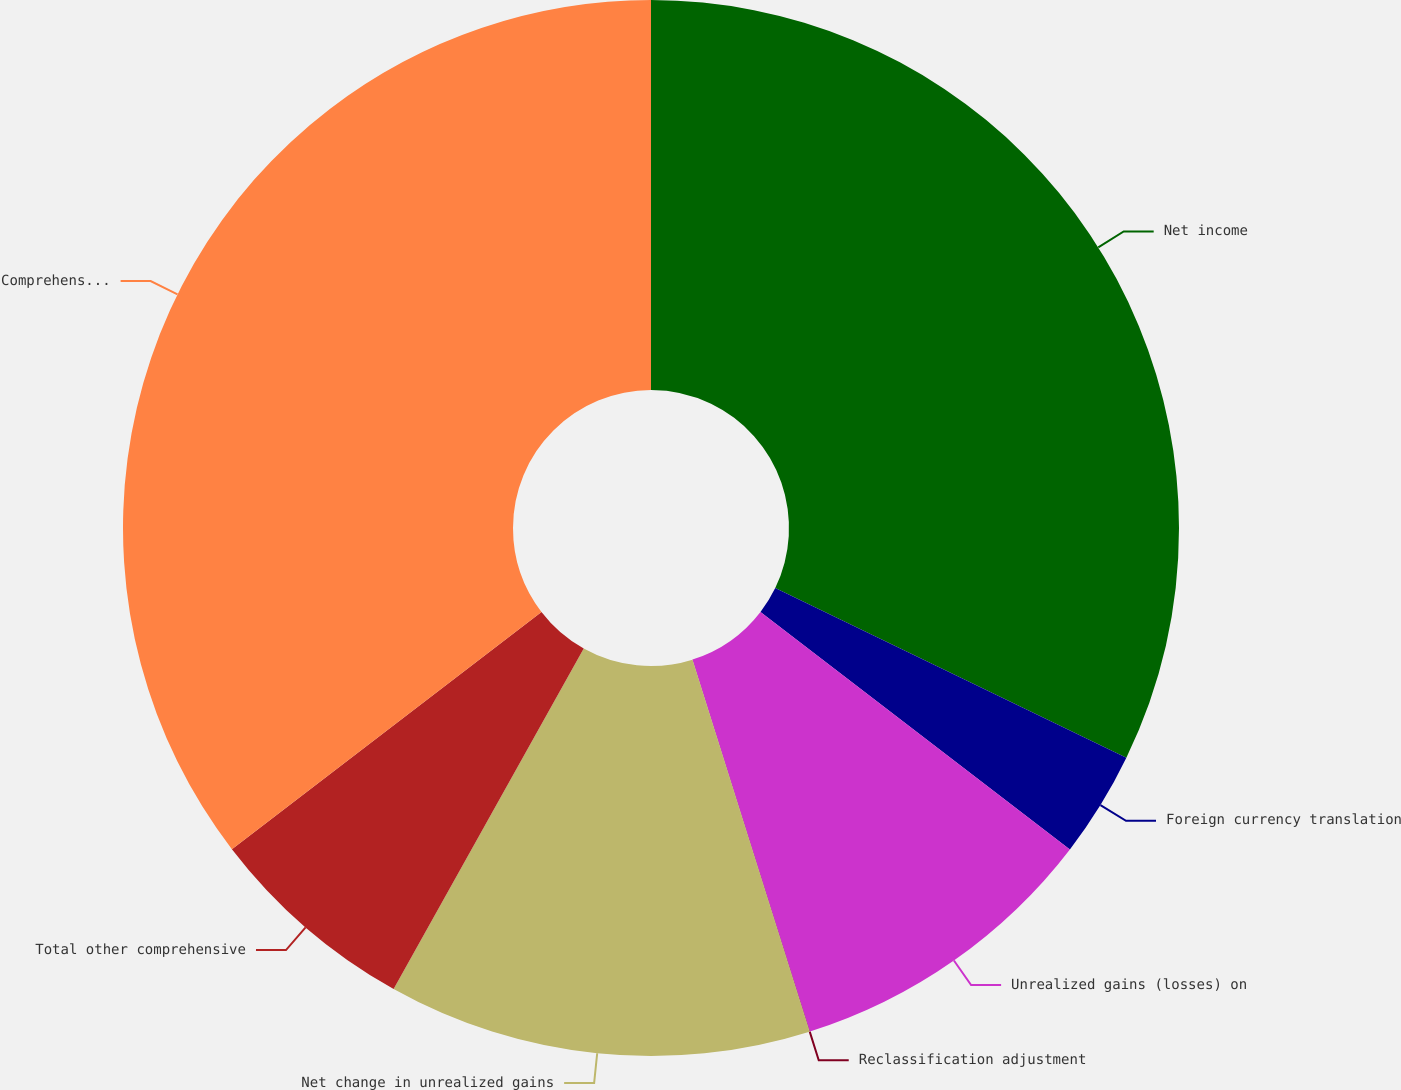<chart> <loc_0><loc_0><loc_500><loc_500><pie_chart><fcel>Net income<fcel>Foreign currency translation<fcel>Unrealized gains (losses) on<fcel>Reclassification adjustment<fcel>Net change in unrealized gains<fcel>Total other comprehensive<fcel>Comprehensive income<nl><fcel>32.17%<fcel>3.25%<fcel>9.72%<fcel>0.01%<fcel>12.96%<fcel>6.49%<fcel>35.41%<nl></chart> 